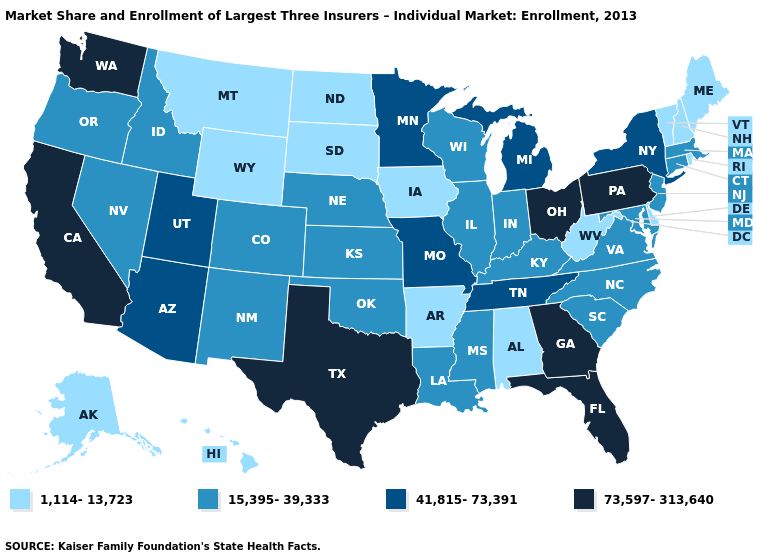Name the states that have a value in the range 41,815-73,391?
Be succinct. Arizona, Michigan, Minnesota, Missouri, New York, Tennessee, Utah. What is the value of Nebraska?
Answer briefly. 15,395-39,333. Name the states that have a value in the range 73,597-313,640?
Short answer required. California, Florida, Georgia, Ohio, Pennsylvania, Texas, Washington. Among the states that border Arizona , does Utah have the lowest value?
Concise answer only. No. What is the highest value in states that border Massachusetts?
Write a very short answer. 41,815-73,391. Among the states that border Oklahoma , which have the highest value?
Quick response, please. Texas. Name the states that have a value in the range 41,815-73,391?
Quick response, please. Arizona, Michigan, Minnesota, Missouri, New York, Tennessee, Utah. Among the states that border Wyoming , which have the highest value?
Write a very short answer. Utah. Among the states that border Oregon , which have the highest value?
Write a very short answer. California, Washington. Does Nevada have the lowest value in the USA?
Short answer required. No. Does the first symbol in the legend represent the smallest category?
Give a very brief answer. Yes. Does the map have missing data?
Give a very brief answer. No. What is the value of North Carolina?
Answer briefly. 15,395-39,333. What is the value of South Dakota?
Write a very short answer. 1,114-13,723. Which states have the lowest value in the USA?
Give a very brief answer. Alabama, Alaska, Arkansas, Delaware, Hawaii, Iowa, Maine, Montana, New Hampshire, North Dakota, Rhode Island, South Dakota, Vermont, West Virginia, Wyoming. 